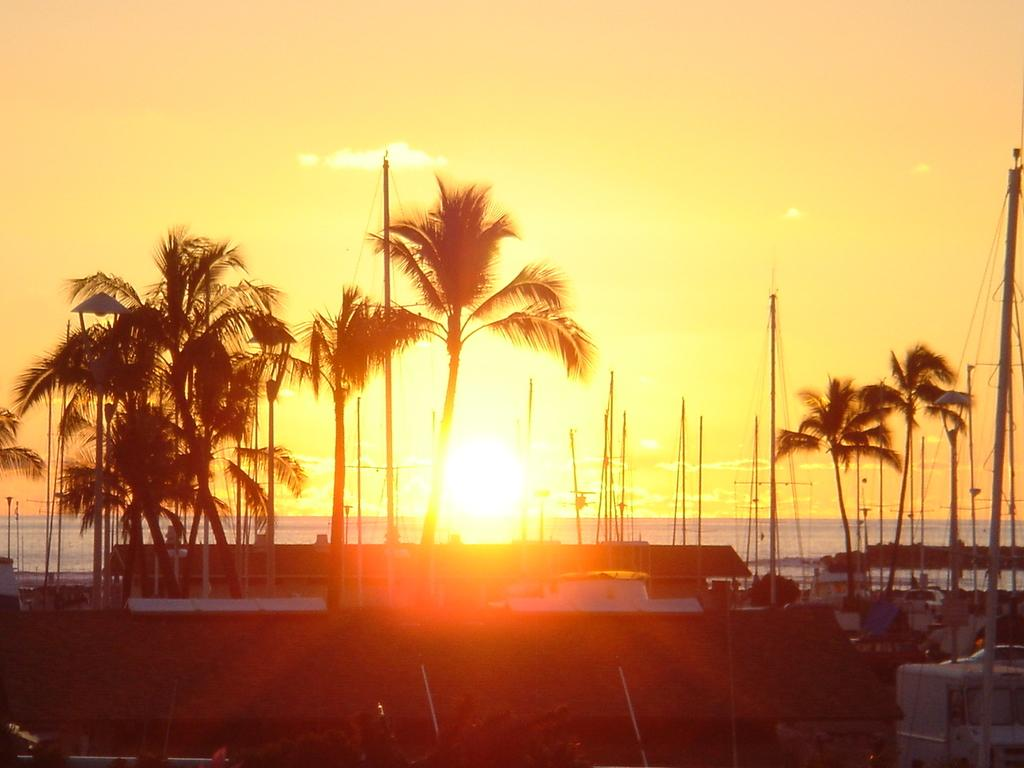What type of vehicles can be seen in the image? There are boats in the image. What type of natural elements are present in the image? There are trees in the image. Can you describe any other objects in the image? There are some objects in the image. What can be seen in the background of the image? There is water and the sky visible in the background of the image. Where is the elbow located in the image? There is no elbow present in the image. What type of medical facility can be seen in the image? There is no hospital or any medical facility present in the image. 